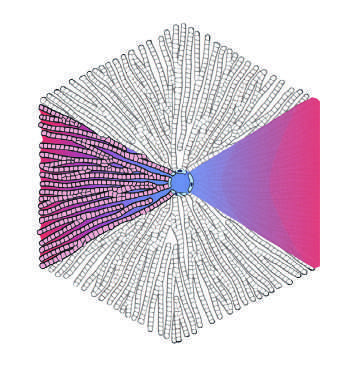who often refers to the regions of the parenchyma as periportal and centrilobular?
Answer the question using a single word or phrase. Pathologists 